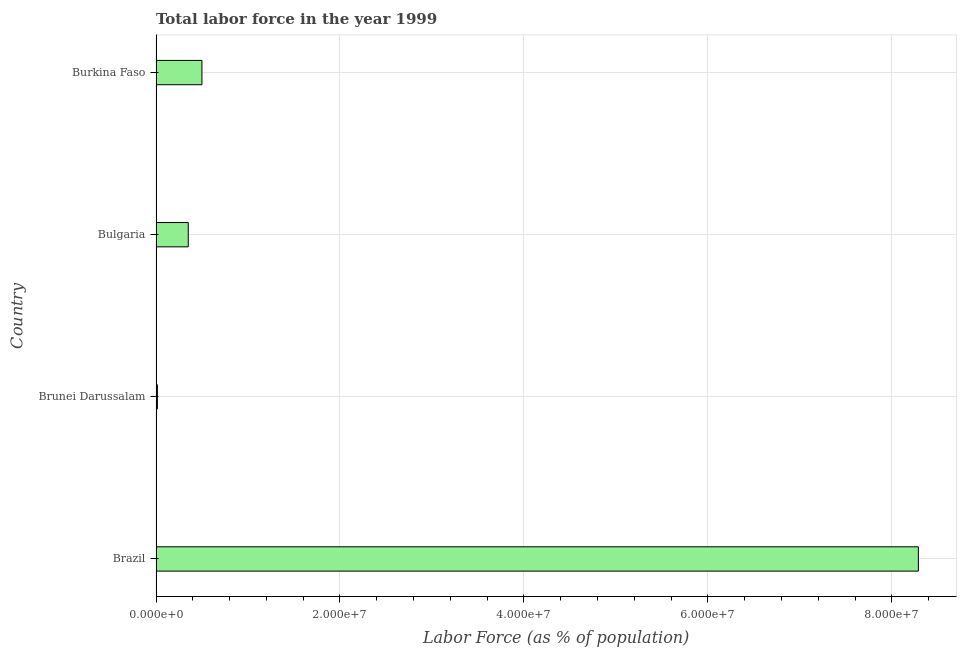Does the graph contain any zero values?
Make the answer very short. No. What is the title of the graph?
Ensure brevity in your answer.  Total labor force in the year 1999. What is the label or title of the X-axis?
Keep it short and to the point. Labor Force (as % of population). What is the total labor force in Brunei Darussalam?
Ensure brevity in your answer.  1.51e+05. Across all countries, what is the maximum total labor force?
Make the answer very short. 8.29e+07. Across all countries, what is the minimum total labor force?
Keep it short and to the point. 1.51e+05. In which country was the total labor force minimum?
Provide a short and direct response. Brunei Darussalam. What is the sum of the total labor force?
Make the answer very short. 9.15e+07. What is the difference between the total labor force in Brazil and Burkina Faso?
Your response must be concise. 7.79e+07. What is the average total labor force per country?
Your response must be concise. 2.29e+07. What is the median total labor force?
Your response must be concise. 4.25e+06. Is the total labor force in Brazil less than that in Brunei Darussalam?
Give a very brief answer. No. Is the difference between the total labor force in Brazil and Bulgaria greater than the difference between any two countries?
Your answer should be compact. No. What is the difference between the highest and the second highest total labor force?
Your answer should be very brief. 7.79e+07. What is the difference between the highest and the lowest total labor force?
Ensure brevity in your answer.  8.27e+07. Are all the bars in the graph horizontal?
Ensure brevity in your answer.  Yes. How many countries are there in the graph?
Keep it short and to the point. 4. What is the difference between two consecutive major ticks on the X-axis?
Keep it short and to the point. 2.00e+07. Are the values on the major ticks of X-axis written in scientific E-notation?
Offer a very short reply. Yes. What is the Labor Force (as % of population) of Brazil?
Keep it short and to the point. 8.29e+07. What is the Labor Force (as % of population) in Brunei Darussalam?
Your answer should be very brief. 1.51e+05. What is the Labor Force (as % of population) of Bulgaria?
Offer a terse response. 3.51e+06. What is the Labor Force (as % of population) in Burkina Faso?
Ensure brevity in your answer.  4.99e+06. What is the difference between the Labor Force (as % of population) in Brazil and Brunei Darussalam?
Give a very brief answer. 8.27e+07. What is the difference between the Labor Force (as % of population) in Brazil and Bulgaria?
Offer a terse response. 7.94e+07. What is the difference between the Labor Force (as % of population) in Brazil and Burkina Faso?
Provide a short and direct response. 7.79e+07. What is the difference between the Labor Force (as % of population) in Brunei Darussalam and Bulgaria?
Offer a terse response. -3.35e+06. What is the difference between the Labor Force (as % of population) in Brunei Darussalam and Burkina Faso?
Your answer should be compact. -4.84e+06. What is the difference between the Labor Force (as % of population) in Bulgaria and Burkina Faso?
Your response must be concise. -1.49e+06. What is the ratio of the Labor Force (as % of population) in Brazil to that in Brunei Darussalam?
Your response must be concise. 550.57. What is the ratio of the Labor Force (as % of population) in Brazil to that in Bulgaria?
Keep it short and to the point. 23.65. What is the ratio of the Labor Force (as % of population) in Brazil to that in Burkina Faso?
Your response must be concise. 16.61. What is the ratio of the Labor Force (as % of population) in Brunei Darussalam to that in Bulgaria?
Your answer should be compact. 0.04. What is the ratio of the Labor Force (as % of population) in Brunei Darussalam to that in Burkina Faso?
Provide a short and direct response. 0.03. What is the ratio of the Labor Force (as % of population) in Bulgaria to that in Burkina Faso?
Your answer should be very brief. 0.7. 